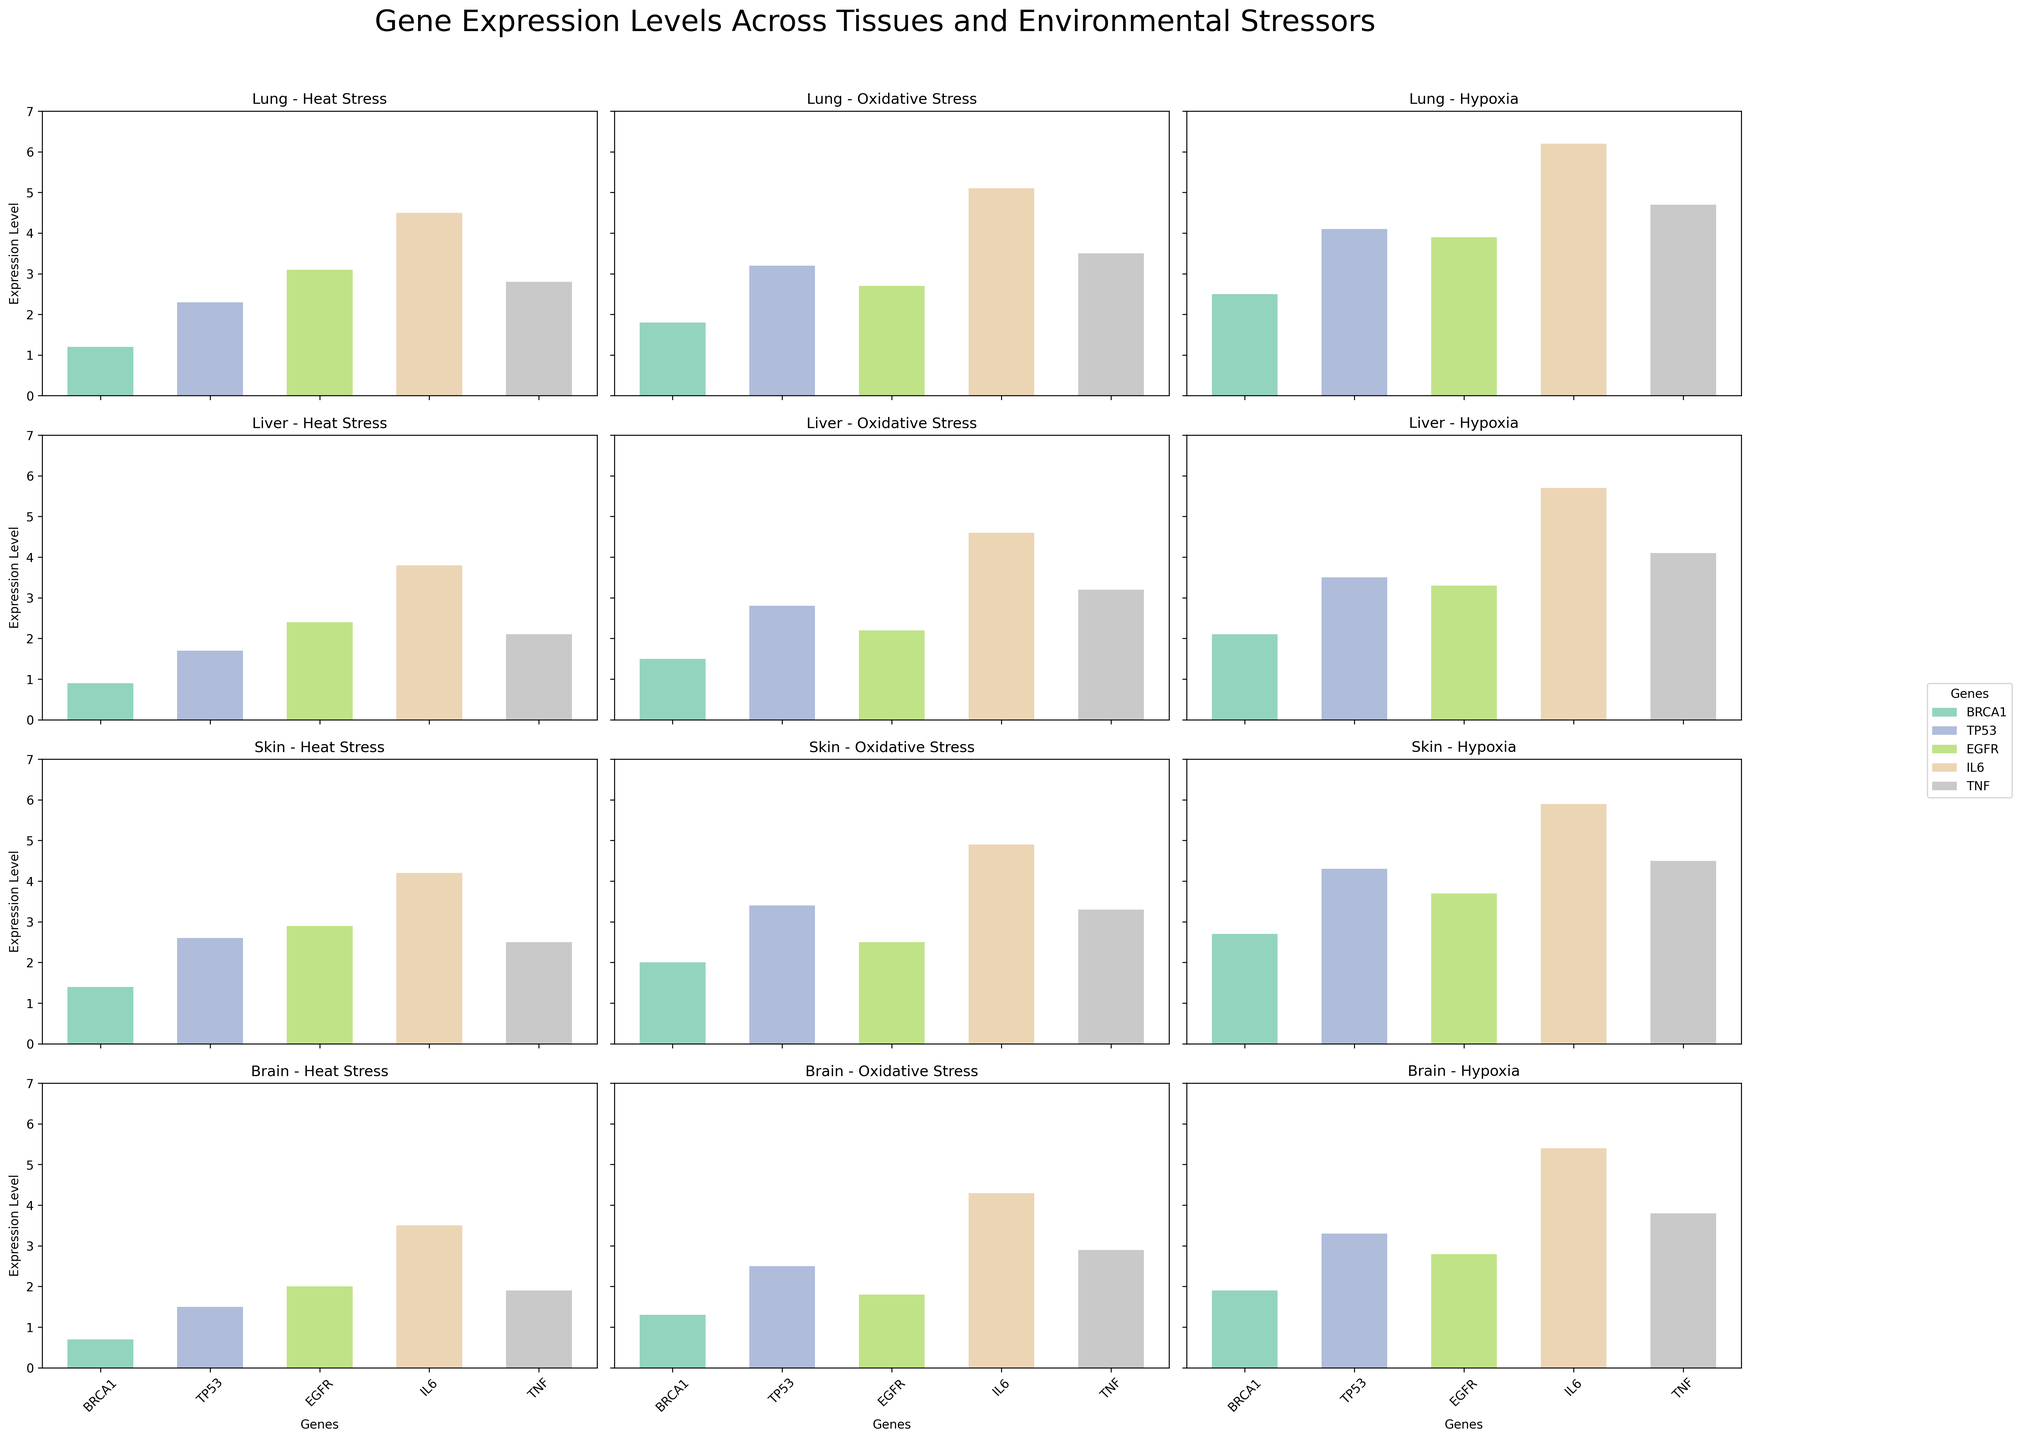What is the title of the overall figure? The title is located at the top of the figure, centered above the grid of subplots. It is larger in font size compared to other text in the figure.
Answer: Gene Expression Levels Across Tissues and Environmental Stressors Which tissue type and stressor combination has the highest expression level of IL6? To find the highest expression level of IL6, compare all IL6 bars across all subplot grids for different tissue and stressor combinations.
Answer: Lung - Hypoxia Which tissue under oxidative stress shows the lowest expression level of BRCA1? Compare the bar heights representing BRCA1 levels for the oxidative stress subplots of each tissue type to identify the lowest one.
Answer: Brain What is the overall trend of TP53 expression in the Lung tissue across different stressors? Look at the bar heights of TP53 in the Lung rows across the different stressor columns to determine the trend. They are arranged in the order of increasing environmental stress effect.
Answer: Increasing In which tissue and under which environmental stressor is TNF expression approximately equal to 3.2? Check each subplot for the TNF bar height closest to 3.2 and identify the corresponding tissue and stressor combination.
Answer: Liver - Oxidative Stress Which tissue under hypoxia shows the highest expression level of EGFR? Compare the bar heights representing EGFR levels for the hypoxia subplots of each tissue type to find the tallest one.
Answer: Lung How does the expression of BRCA1 in Brain tissues compare between heat stress and hypoxia? Look at the heights of the BRCA1 bars in the Brain row under heat stress and hypoxia subplots to make the comparison.
Answer: Higher in Hypoxia What's the average expression level of TNF across all tissue types under heat stress? Sum the TNF bars under heat stress for all tissues and divide by the number of tissues. (2.8 + 2.1 + 2.5 + 1.9) / 4.
Answer: 2.325 What is the difference in IL6 expression between Lung and Liver tissues under hypoxia? Subtract the IL6 expression level of Liver under hypoxia from that of Lung under hypoxia. 6.2 (Lung) - 5.7 (Liver).
Answer: 0.5 Which gene has the smallest variability in expression levels across all conditions and tissues? Analyze the bar heights of each gene across all subplots to identify which one has the smallest range of expression levels.
Answer: BRCA1 